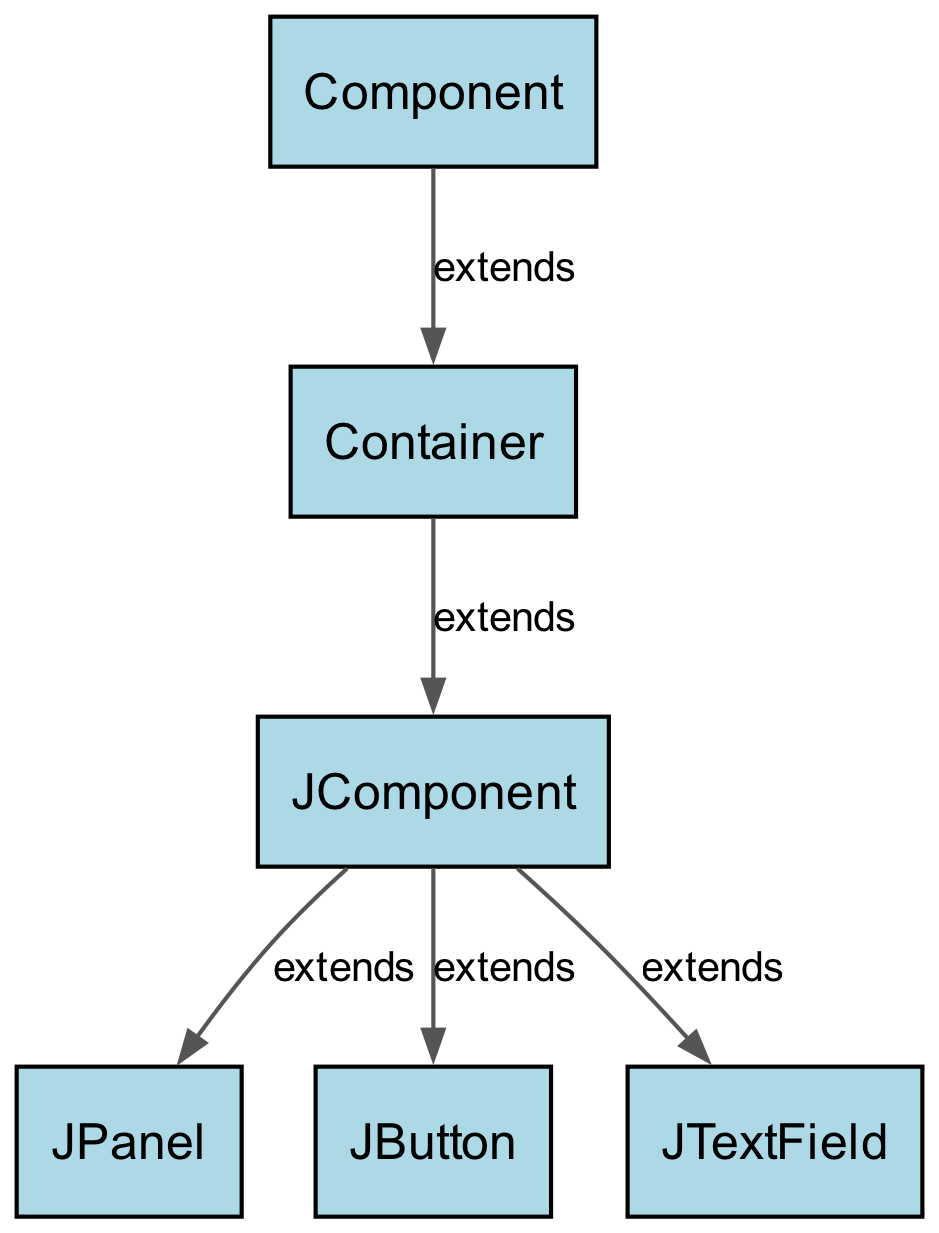What is the total number of nodes in the diagram? The diagram includes six nodes: Component, Container, JComponent, JPanel, JButton, and JTextField. By counting each of the unique entries, we determine that the total number of nodes is six.
Answer: six Which node is at the top of the hierarchy? The hierarchy indicates that Component is the top-most node, as it is the only node with no nodes pointing to it. All other components extend from Component.
Answer: Component How many edges are present in the diagram? By counting the connections (or edges) represented in the diagram, we find that there are five edges, each representing an "extends" relationship between the classes.
Answer: five Which component is a subclass of JComponent and represents a container? The diagram shows that JPanel extends from JComponent. Since JPanel is a container for other components in Swing, it is the correct answer here.
Answer: JPanel What is the direct parent class of JButton? In the diagram, JButton extends from JComponent, meaning JComponent is the direct superclass of JButton. The relationship illustrates that JButton derives its properties from JComponent.
Answer: JComponent Which two components directly extend from JComponent? The diagram indicates that JButton and JTextField are both directly connected to JComponent as its subclasses. Thus, these are the two components derived from JComponent.
Answer: JButton and JTextField What relationship type connects the Component node to the Container node? The diagram specifies that the relationship between Component and Container is labeled "extends," indicating that Container is a subclass of Component. This shows the inheritance hierarchy.
Answer: extends Which class serves as a container but is not directly labeled as a component in the diagram? The diagram illustrates that JPanel, which extends from JComponent (and consequently from Container), functions as a container. While it is a component, it's also specifically utilized as a container in GUI design.
Answer: JPanel How many components extend from JComponent? There are three components extending from JComponent as shown in the diagram: JPanel, JButton, and JTextField. Counting them provides the answer to the question regarding the subclasses of JComponent.
Answer: three 